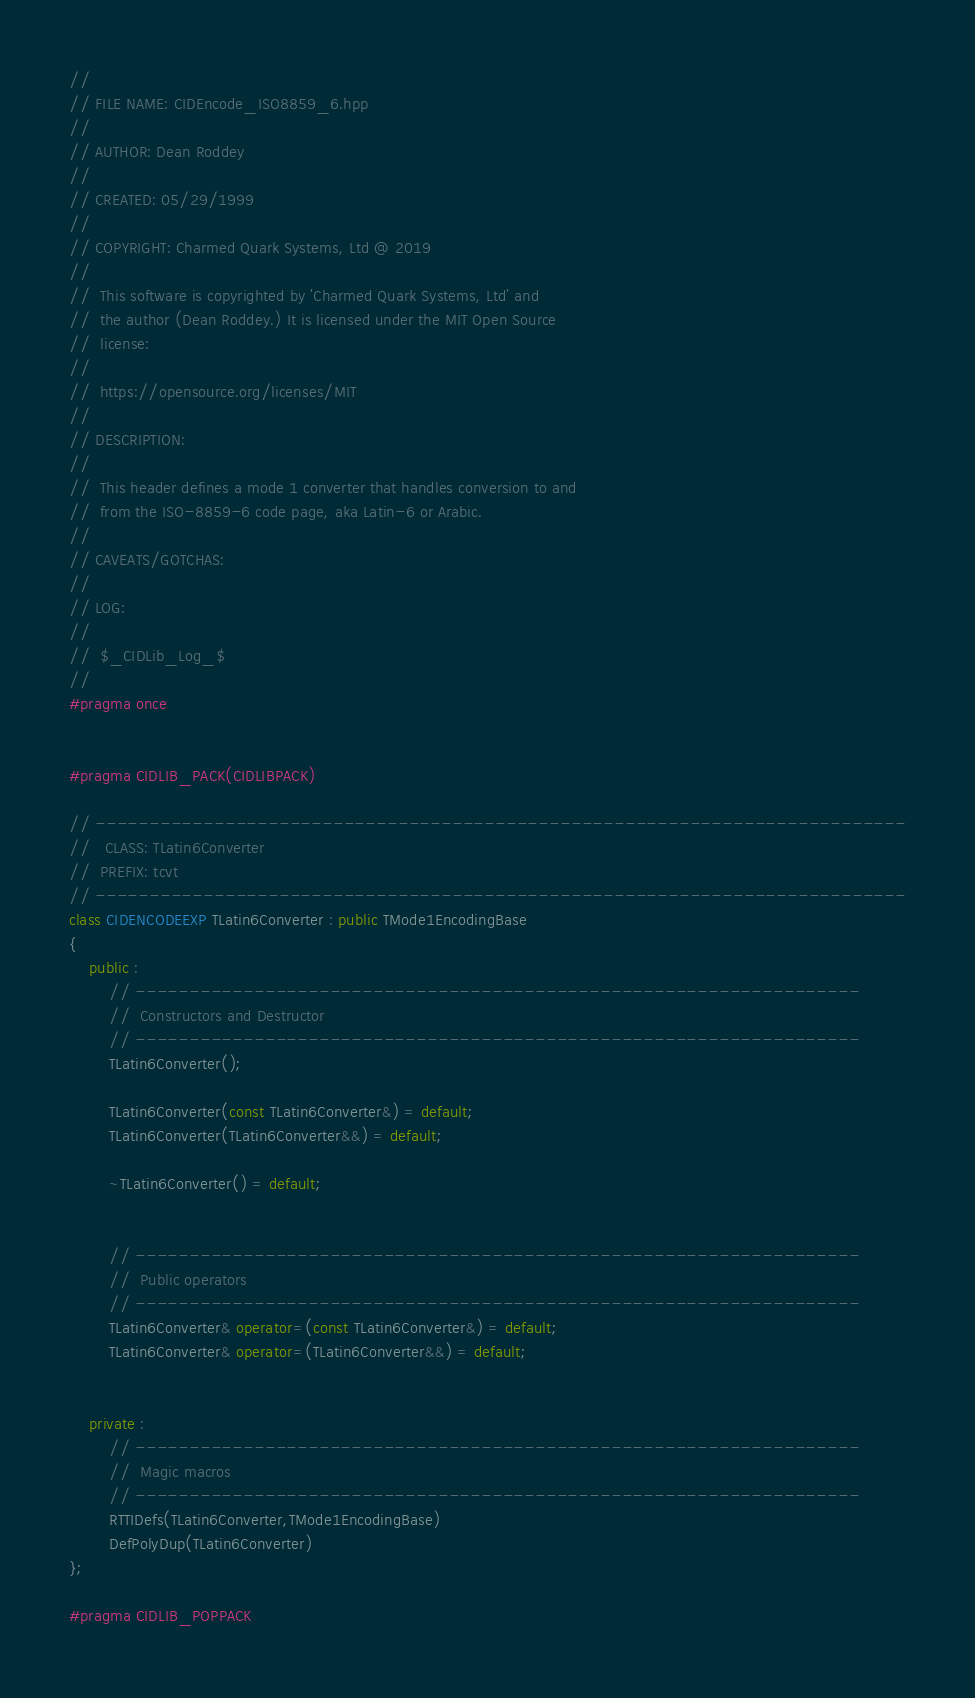Convert code to text. <code><loc_0><loc_0><loc_500><loc_500><_C++_>//
// FILE NAME: CIDEncode_ISO8859_6.hpp
//
// AUTHOR: Dean Roddey
//
// CREATED: 05/29/1999
//
// COPYRIGHT: Charmed Quark Systems, Ltd @ 2019
//
//  This software is copyrighted by 'Charmed Quark Systems, Ltd' and
//  the author (Dean Roddey.) It is licensed under the MIT Open Source
//  license:
//
//  https://opensource.org/licenses/MIT
//
// DESCRIPTION:
//
//  This header defines a mode 1 converter that handles conversion to and
//  from the ISO-8859-6 code page, aka Latin-6 or Arabic.
//
// CAVEATS/GOTCHAS:
//
// LOG:
//
//  $_CIDLib_Log_$
//
#pragma once


#pragma CIDLIB_PACK(CIDLIBPACK)

// ---------------------------------------------------------------------------
//   CLASS: TLatin6Converter
//  PREFIX: tcvt
// ---------------------------------------------------------------------------
class CIDENCODEEXP TLatin6Converter : public TMode1EncodingBase
{
    public :
        // -------------------------------------------------------------------
        //  Constructors and Destructor
        // -------------------------------------------------------------------
        TLatin6Converter();

        TLatin6Converter(const TLatin6Converter&) = default;
        TLatin6Converter(TLatin6Converter&&) = default;

        ~TLatin6Converter() = default;


        // -------------------------------------------------------------------
        //  Public operators
        // -------------------------------------------------------------------
        TLatin6Converter& operator=(const TLatin6Converter&) = default;
        TLatin6Converter& operator=(TLatin6Converter&&) = default;


    private :
        // -------------------------------------------------------------------
        //  Magic macros
        // -------------------------------------------------------------------
        RTTIDefs(TLatin6Converter,TMode1EncodingBase)
        DefPolyDup(TLatin6Converter)
};

#pragma CIDLIB_POPPACK


</code> 